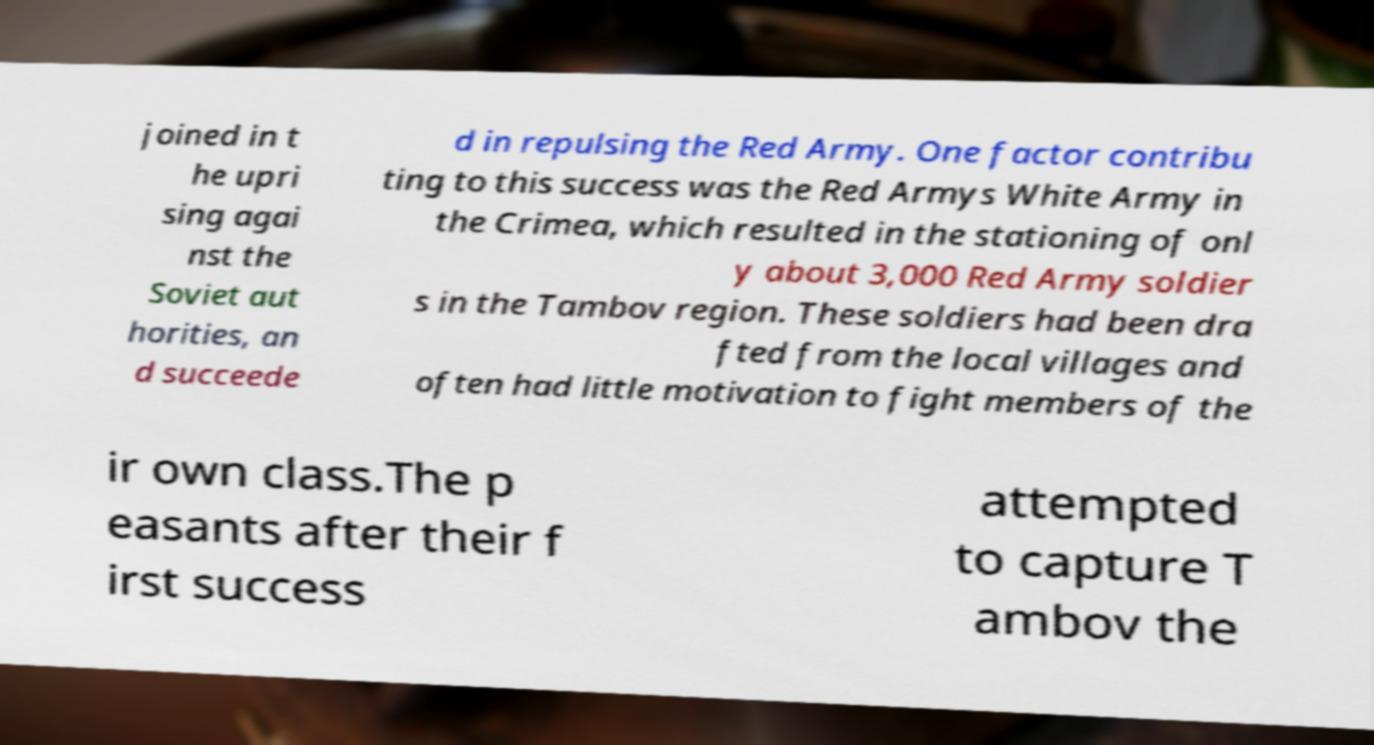For documentation purposes, I need the text within this image transcribed. Could you provide that? joined in t he upri sing agai nst the Soviet aut horities, an d succeede d in repulsing the Red Army. One factor contribu ting to this success was the Red Armys White Army in the Crimea, which resulted in the stationing of onl y about 3,000 Red Army soldier s in the Tambov region. These soldiers had been dra fted from the local villages and often had little motivation to fight members of the ir own class.The p easants after their f irst success attempted to capture T ambov the 